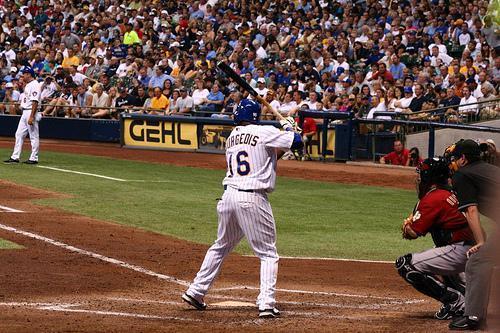How many people are visible?
Give a very brief answer. 4. How many giraffes have dark spots?
Give a very brief answer. 0. 